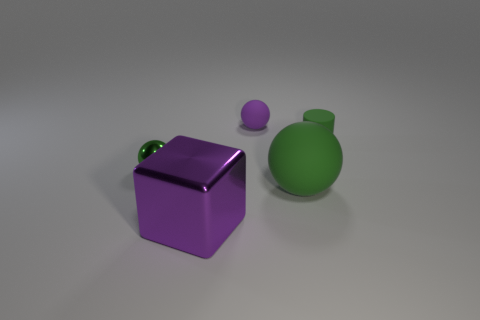What number of tiny green cylinders are there?
Your response must be concise. 1. What shape is the object that is made of the same material as the cube?
Offer a very short reply. Sphere. Does the rubber object that is behind the small green cylinder have the same color as the large object to the left of the purple ball?
Make the answer very short. Yes. Are there an equal number of big green matte spheres left of the block and small yellow shiny cubes?
Ensure brevity in your answer.  Yes. How many green balls are left of the purple metal thing?
Offer a very short reply. 1. How big is the purple metal thing?
Your answer should be very brief. Large. There is a cylinder that is made of the same material as the large green thing; what is its color?
Provide a short and direct response. Green. How many green rubber objects are the same size as the green matte sphere?
Your response must be concise. 0. Is the purple object that is behind the large green ball made of the same material as the big green thing?
Ensure brevity in your answer.  Yes. Is the number of green matte things in front of the large matte object less than the number of big purple blocks?
Offer a very short reply. Yes. 